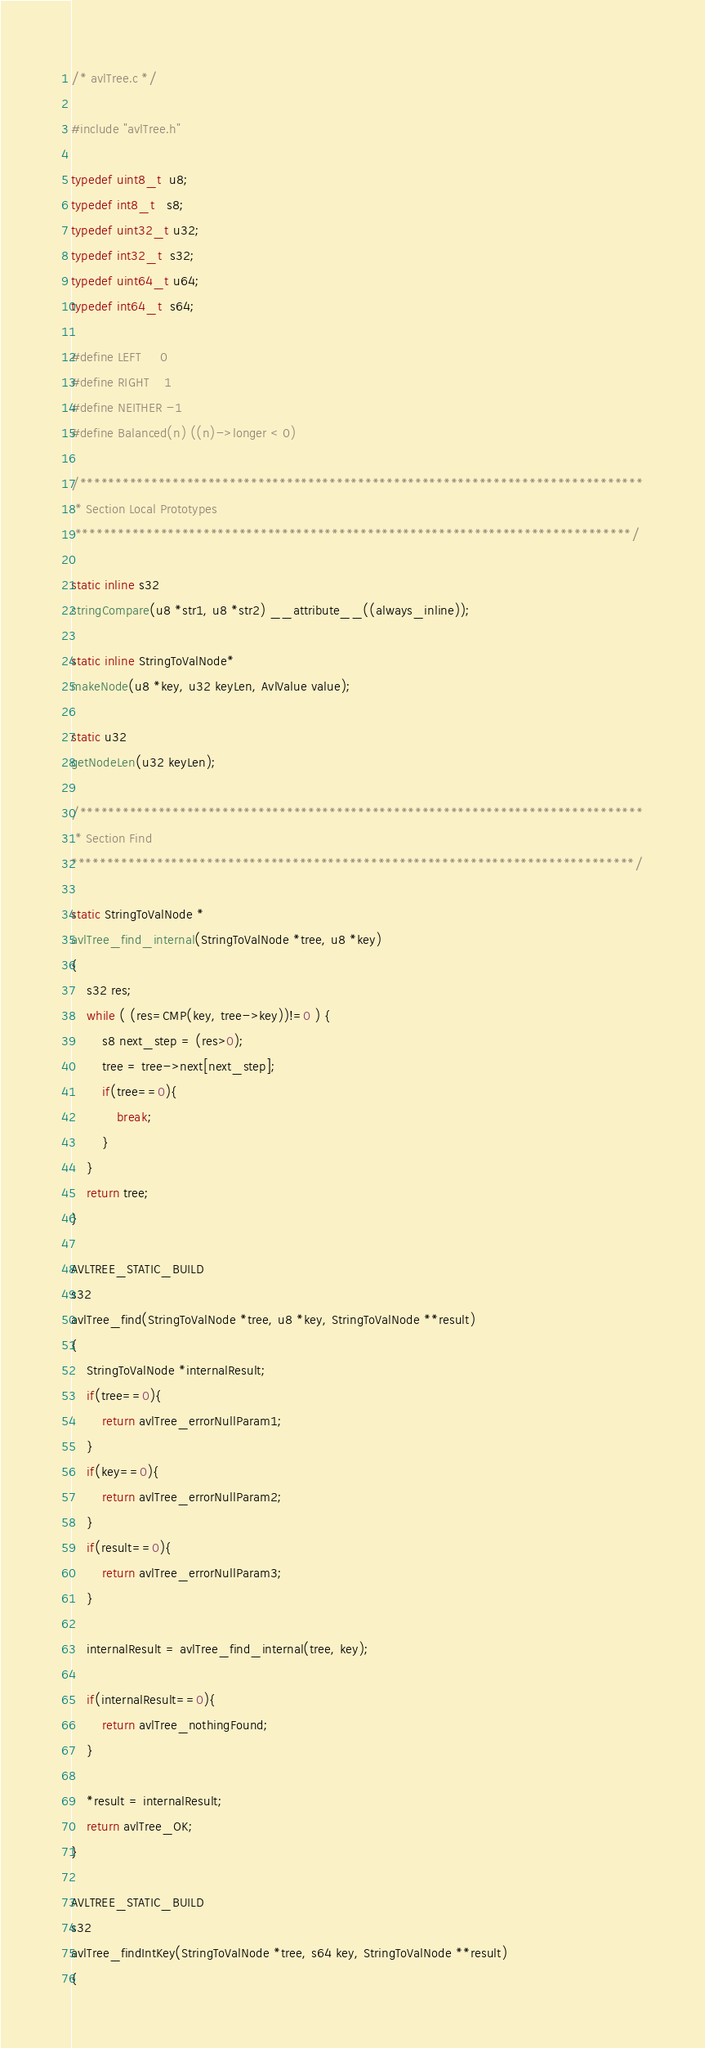Convert code to text. <code><loc_0><loc_0><loc_500><loc_500><_C_>/* avlTree.c */

#include "avlTree.h"

typedef uint8_t  u8;
typedef int8_t   s8;
typedef uint32_t u32;
typedef int32_t  s32;
typedef uint64_t u64;
typedef int64_t  s64;

#define LEFT     0
#define RIGHT    1
#define NEITHER -1
#define Balanced(n) ((n)->longer < 0)

/*******************************************************************************
 * Section Local Prototypes
 ******************************************************************************/

static inline s32
stringCompare(u8 *str1, u8 *str2) __attribute__((always_inline));

static inline StringToValNode*
makeNode(u8 *key, u32 keyLen, AvlValue value);

static u32
getNodeLen(u32 keyLen);

/*******************************************************************************
 * Section Find
*******************************************************************************/

static StringToValNode *
avlTree_find_internal(StringToValNode *tree, u8 *key)
{
	s32 res;
	while ( (res=CMP(key, tree->key))!=0 ) {
		s8 next_step = (res>0);
		tree = tree->next[next_step];
		if(tree==0){
			break;
		}
	}
	return tree;
}

AVLTREE_STATIC_BUILD
s32
avlTree_find(StringToValNode *tree, u8 *key, StringToValNode **result)
{
	StringToValNode *internalResult;
	if(tree==0){
		return avlTree_errorNullParam1;
	}
	if(key==0){
		return avlTree_errorNullParam2;
	}
	if(result==0){
		return avlTree_errorNullParam3;
	}
	
	internalResult = avlTree_find_internal(tree, key);
	
	if(internalResult==0){
		return avlTree_nothingFound;
	}

	*result = internalResult;
	return avlTree_OK;
}

AVLTREE_STATIC_BUILD
s32
avlTree_findIntKey(StringToValNode *tree, s64 key, StringToValNode **result)
{</code> 